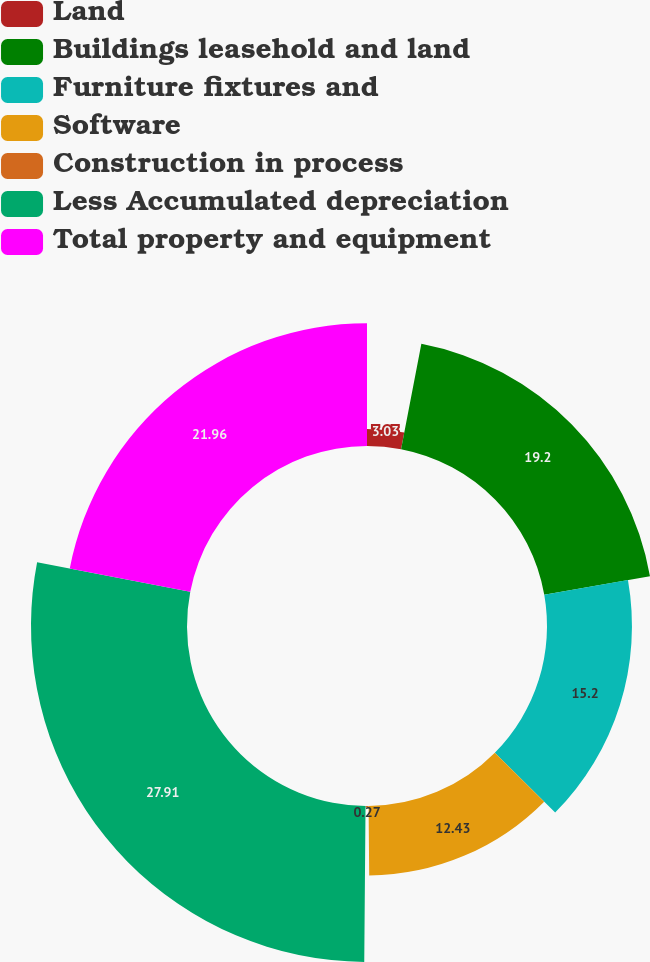Convert chart to OTSL. <chart><loc_0><loc_0><loc_500><loc_500><pie_chart><fcel>Land<fcel>Buildings leasehold and land<fcel>Furniture fixtures and<fcel>Software<fcel>Construction in process<fcel>Less Accumulated depreciation<fcel>Total property and equipment<nl><fcel>3.03%<fcel>19.2%<fcel>15.2%<fcel>12.43%<fcel>0.27%<fcel>27.91%<fcel>21.96%<nl></chart> 